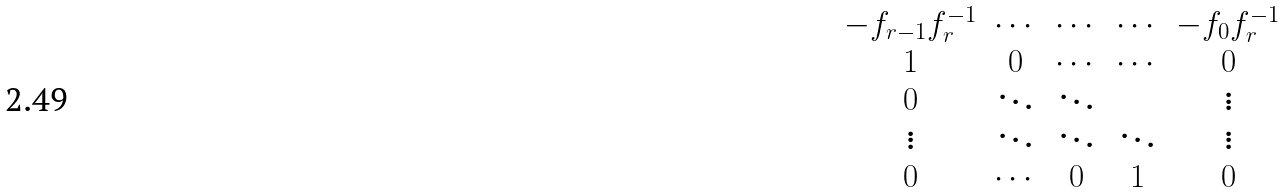Convert formula to latex. <formula><loc_0><loc_0><loc_500><loc_500>\begin{matrix} - f _ { r - 1 } f _ { r } ^ { - 1 } & \cdots & \cdots & \cdots & - f _ { 0 } f _ { r } ^ { - 1 } \\ 1 & 0 & \cdots & \cdots & 0 \\ 0 & \ddots & \ddots & & \vdots \\ \vdots & \ddots & \ddots & \ddots & \vdots \\ 0 & \cdots & 0 & 1 & 0 \\ \end{matrix}</formula> 